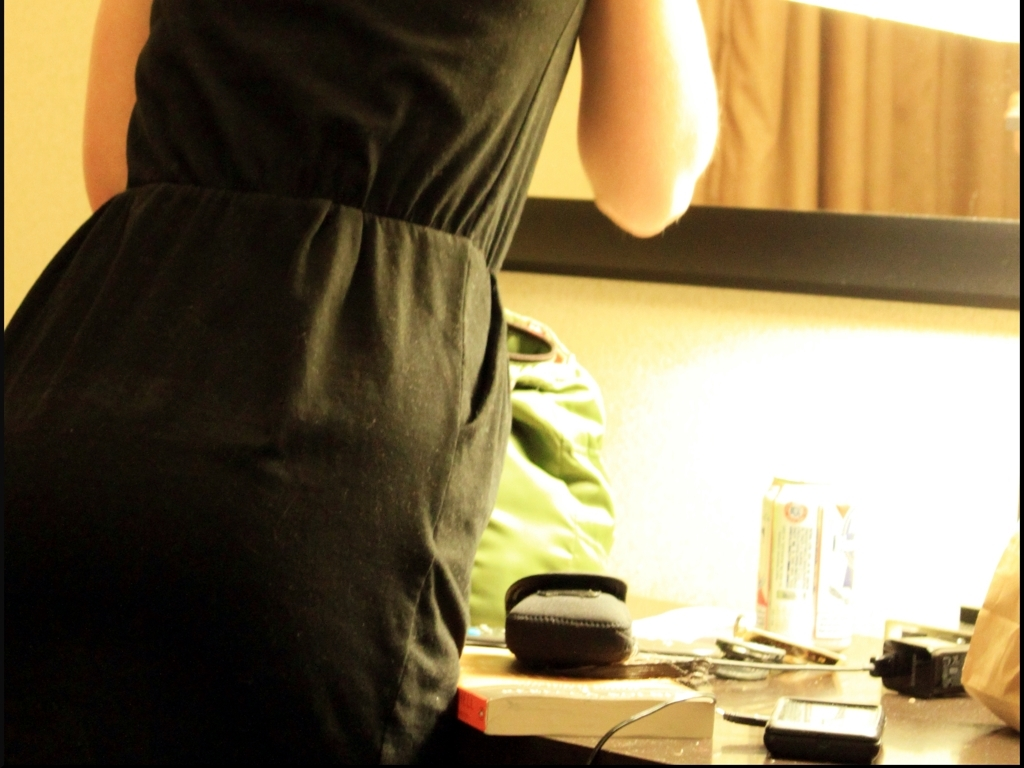Are there any quality issues with this image? The image exhibits several quality issues including blurriness, poor lighting conditions, lack of focus, and composition that does not clearly present a subject. The lower part of the image is overexposed, resulting in loss of detail. Additionally, the cluttered background and random objects in the foreground distract from any potential focal point. Improving the sharpness, adjusting the lighting, and choosing a clear subject would greatly enhance the quality of the photograph. 